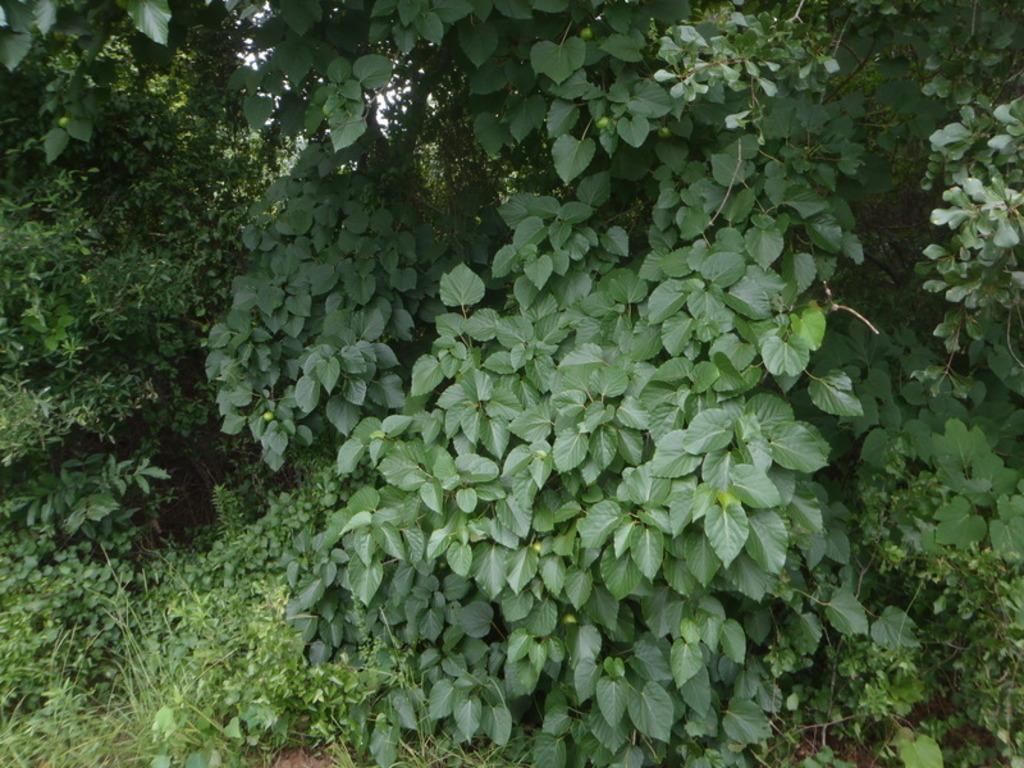Please provide a concise description of this image. In this picture we can see some grass on the ground. There are a few plants and trees throughout the image. 